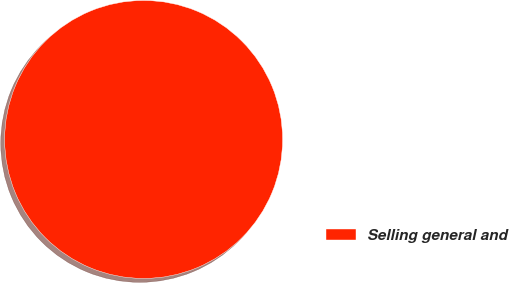Convert chart. <chart><loc_0><loc_0><loc_500><loc_500><pie_chart><fcel>Selling general and<nl><fcel>100.0%<nl></chart> 